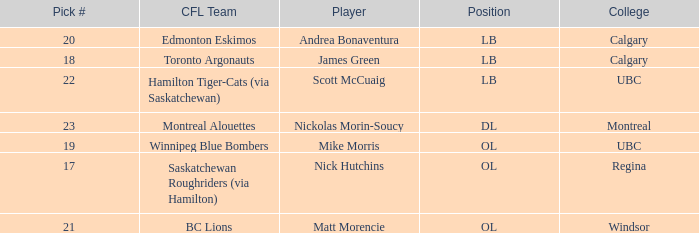What number picks were the players who went to Calgary?  18, 20. 